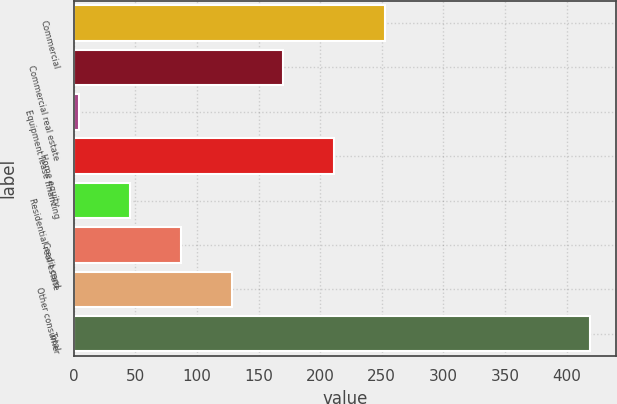Convert chart. <chart><loc_0><loc_0><loc_500><loc_500><bar_chart><fcel>Commercial<fcel>Commercial real estate<fcel>Equipment lease financing<fcel>Home equity<fcel>Residential real estate<fcel>Credit card<fcel>Other consumer<fcel>Total<nl><fcel>253<fcel>170<fcel>4<fcel>211.5<fcel>45.5<fcel>87<fcel>128.5<fcel>419<nl></chart> 